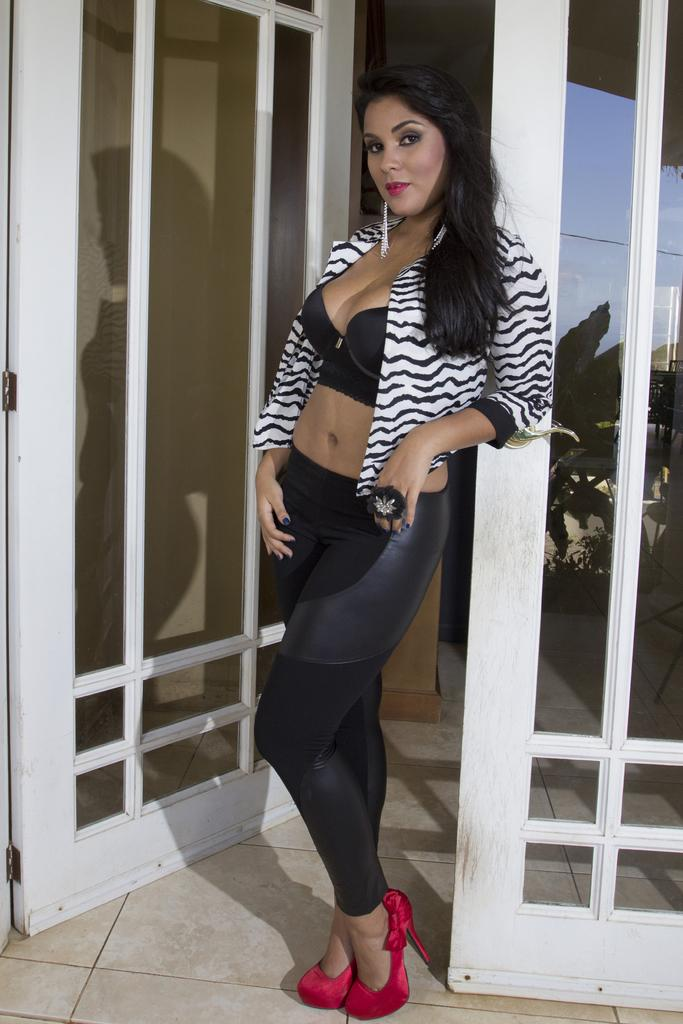Who is the main subject in the image? There is a woman in the image. Where is the woman located in the image? The woman is in the center of the image. What is the woman standing beside in the image? The woman is standing beside a door. What type of clothing is the woman wearing on her upper body? The woman is wearing a shrug. What type of pants is the woman wearing? The woman is wearing black trousers. What type of amusement can be seen in the image? There is no amusement present in the image; it features a woman standing beside a door. What breed of dog is the woman holding in the image? There is no dog present in the image. 